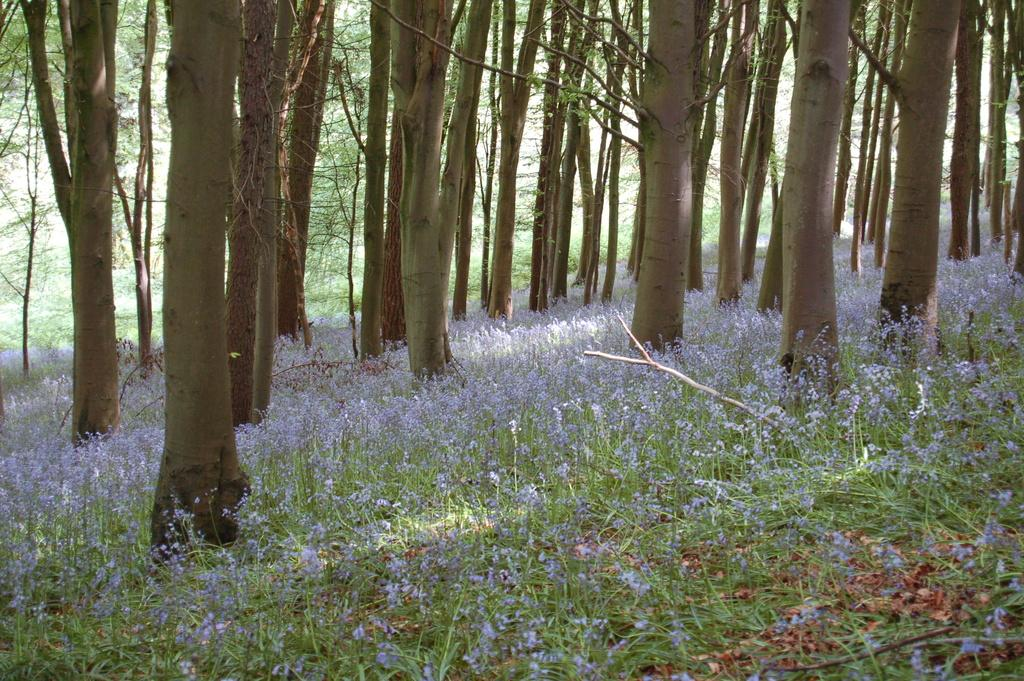What is the main feature in the center of the image? There are trees in the center of the image. What type of vegetation is present at the bottom of the image? There is grass and flowers at the bottom of the image. What type of apparel is the grandmother wearing in the image? There is no grandmother present in the image, so we cannot answer any questions about her apparel. 